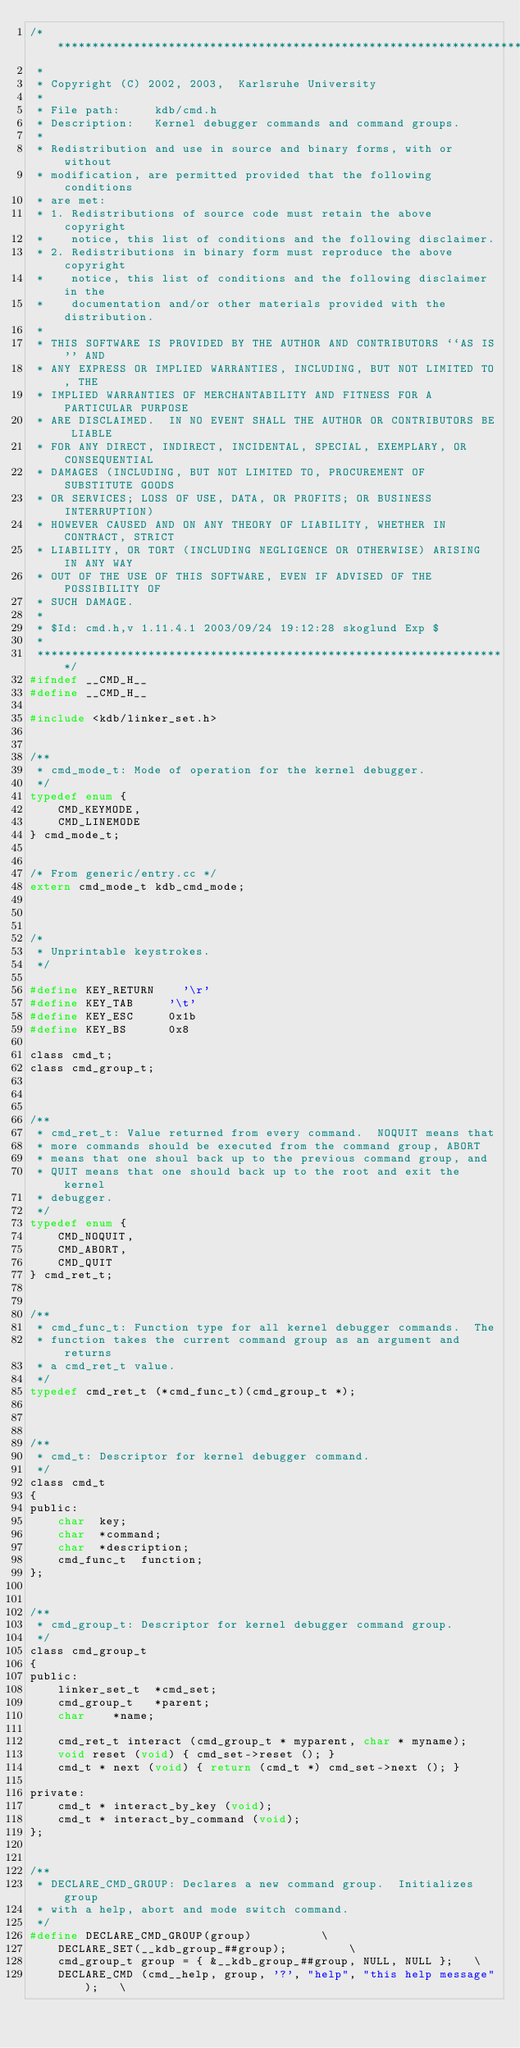Convert code to text. <code><loc_0><loc_0><loc_500><loc_500><_C_>/*********************************************************************
 *                
 * Copyright (C) 2002, 2003,  Karlsruhe University
 *                
 * File path:     kdb/cmd.h
 * Description:   Kernel debugger commands and command groups.
 *                
 * Redistribution and use in source and binary forms, with or without
 * modification, are permitted provided that the following conditions
 * are met:
 * 1. Redistributions of source code must retain the above copyright
 *    notice, this list of conditions and the following disclaimer.
 * 2. Redistributions in binary form must reproduce the above copyright
 *    notice, this list of conditions and the following disclaimer in the
 *    documentation and/or other materials provided with the distribution.
 * 
 * THIS SOFTWARE IS PROVIDED BY THE AUTHOR AND CONTRIBUTORS ``AS IS'' AND
 * ANY EXPRESS OR IMPLIED WARRANTIES, INCLUDING, BUT NOT LIMITED TO, THE
 * IMPLIED WARRANTIES OF MERCHANTABILITY AND FITNESS FOR A PARTICULAR PURPOSE
 * ARE DISCLAIMED.  IN NO EVENT SHALL THE AUTHOR OR CONTRIBUTORS BE LIABLE
 * FOR ANY DIRECT, INDIRECT, INCIDENTAL, SPECIAL, EXEMPLARY, OR CONSEQUENTIAL
 * DAMAGES (INCLUDING, BUT NOT LIMITED TO, PROCUREMENT OF SUBSTITUTE GOODS
 * OR SERVICES; LOSS OF USE, DATA, OR PROFITS; OR BUSINESS INTERRUPTION)
 * HOWEVER CAUSED AND ON ANY THEORY OF LIABILITY, WHETHER IN CONTRACT, STRICT
 * LIABILITY, OR TORT (INCLUDING NEGLIGENCE OR OTHERWISE) ARISING IN ANY WAY
 * OUT OF THE USE OF THIS SOFTWARE, EVEN IF ADVISED OF THE POSSIBILITY OF
 * SUCH DAMAGE.
 *                
 * $Id: cmd.h,v 1.11.4.1 2003/09/24 19:12:28 skoglund Exp $
 *                
 ********************************************************************/
#ifndef __CMD_H__
#define __CMD_H__

#include <kdb/linker_set.h>


/**
 * cmd_mode_t: Mode of operation for the kernel debugger.
 */
typedef enum {
    CMD_KEYMODE,
    CMD_LINEMODE
} cmd_mode_t;


/* From generic/entry.cc */
extern cmd_mode_t kdb_cmd_mode;



/*
 * Unprintable keystrokes.
 */

#define KEY_RETURN		'\r'
#define KEY_TAB			'\t'
#define KEY_ESC			0x1b
#define KEY_BS			0x8

class cmd_t;
class cmd_group_t;



/**
 * cmd_ret_t: Value returned from every command.  NOQUIT means that
 * more commands should be executed from the command group, ABORT
 * means that one shoul back up to the previous command group, and
 * QUIT means that one should back up to the root and exit the kernel
 * debugger.
 */
typedef enum {
    CMD_NOQUIT,
    CMD_ABORT,
    CMD_QUIT
} cmd_ret_t;


/**
 * cmd_func_t: Function type for all kernel debugger commands.  The
 * function takes the current command group as an argument and returns
 * a cmd_ret_t value.
 */
typedef cmd_ret_t (*cmd_func_t)(cmd_group_t *);



/**
 * cmd_t: Descriptor for kernel debugger command.
 */
class cmd_t
{
public:
    char	key;
    char	*command;
    char	*description;
    cmd_func_t	function;
};


/**
 * cmd_group_t: Descriptor for kernel debugger command group.
 */
class cmd_group_t
{
public:
    linker_set_t	*cmd_set;
    cmd_group_t		*parent;
    char 		*name;

    cmd_ret_t interact (cmd_group_t * myparent, char * myname);
    void reset (void) { cmd_set->reset (); }
    cmd_t * next (void) { return (cmd_t *) cmd_set->next (); }

private:
    cmd_t * interact_by_key (void);
    cmd_t * interact_by_command (void);
};


/**
 * DECLARE_CMD_GROUP: Declares a new command group.  Initializes group
 * with a help, abort and mode switch command.
 */
#define DECLARE_CMD_GROUP(group)					\
    DECLARE_SET(__kdb_group_##group);					\
    cmd_group_t group = { &__kdb_group_##group, NULL, NULL };		\
    DECLARE_CMD (cmd__help, group, '?', "help", "this help message");   \</code> 